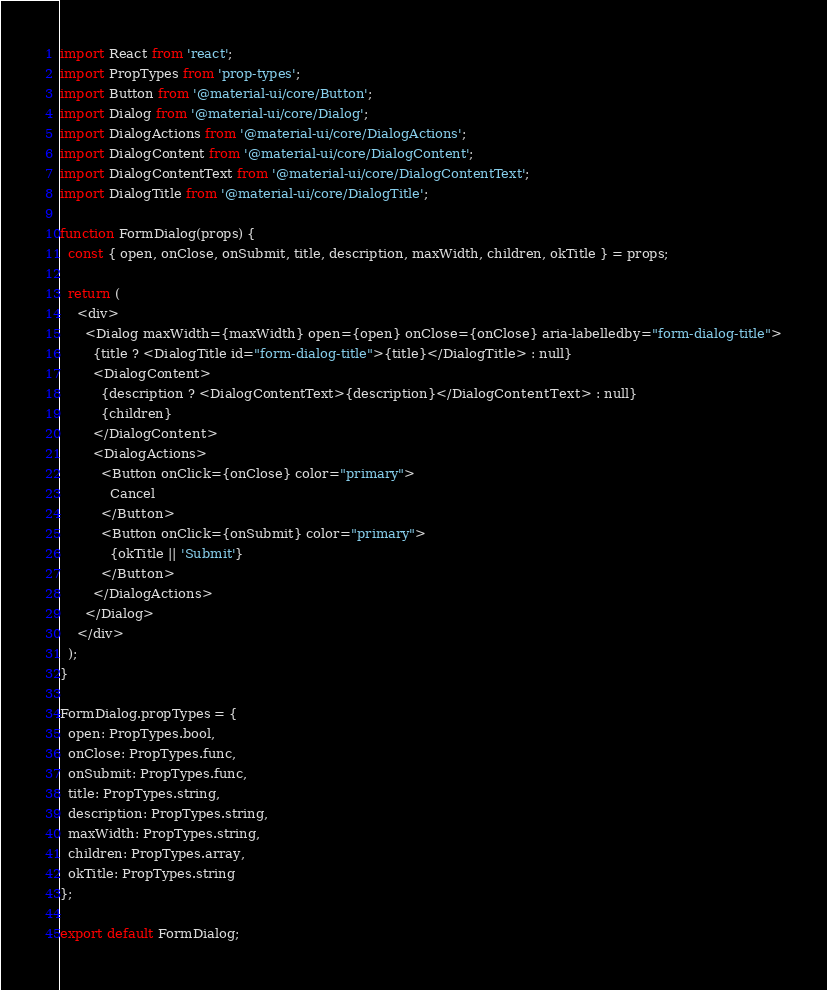<code> <loc_0><loc_0><loc_500><loc_500><_JavaScript_>import React from 'react';
import PropTypes from 'prop-types';
import Button from '@material-ui/core/Button';
import Dialog from '@material-ui/core/Dialog';
import DialogActions from '@material-ui/core/DialogActions';
import DialogContent from '@material-ui/core/DialogContent';
import DialogContentText from '@material-ui/core/DialogContentText';
import DialogTitle from '@material-ui/core/DialogTitle';

function FormDialog(props) {
  const { open, onClose, onSubmit, title, description, maxWidth, children, okTitle } = props;

  return (
    <div>
      <Dialog maxWidth={maxWidth} open={open} onClose={onClose} aria-labelledby="form-dialog-title">
        {title ? <DialogTitle id="form-dialog-title">{title}</DialogTitle> : null}
        <DialogContent>
          {description ? <DialogContentText>{description}</DialogContentText> : null}
          {children}
        </DialogContent>
        <DialogActions>
          <Button onClick={onClose} color="primary">
            Cancel
          </Button>
          <Button onClick={onSubmit} color="primary">
            {okTitle || 'Submit'}
          </Button>
        </DialogActions>
      </Dialog>
    </div>
  );
}

FormDialog.propTypes = {
  open: PropTypes.bool,
  onClose: PropTypes.func,
  onSubmit: PropTypes.func,
  title: PropTypes.string,
  description: PropTypes.string,
  maxWidth: PropTypes.string,
  children: PropTypes.array,
  okTitle: PropTypes.string
};

export default FormDialog;
</code> 